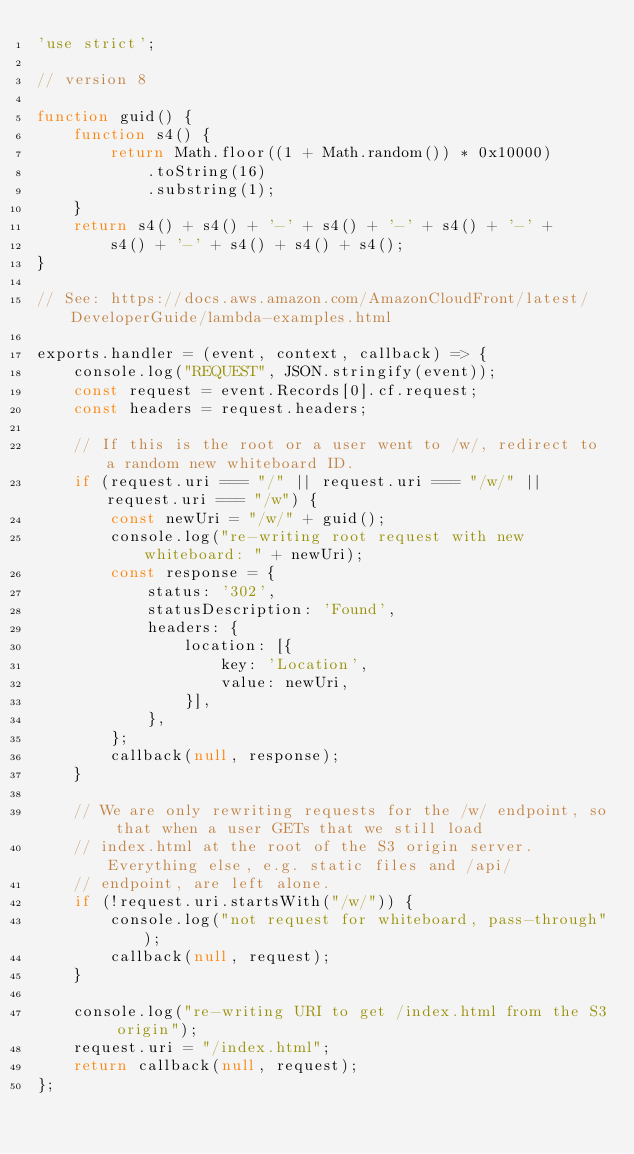Convert code to text. <code><loc_0><loc_0><loc_500><loc_500><_JavaScript_>'use strict';

// version 8

function guid() {
    function s4() {
        return Math.floor((1 + Math.random()) * 0x10000)
            .toString(16)
            .substring(1);
    }
    return s4() + s4() + '-' + s4() + '-' + s4() + '-' +
        s4() + '-' + s4() + s4() + s4();
}

// See: https://docs.aws.amazon.com/AmazonCloudFront/latest/DeveloperGuide/lambda-examples.html

exports.handler = (event, context, callback) => {
    console.log("REQUEST", JSON.stringify(event));
    const request = event.Records[0].cf.request;
    const headers = request.headers;

    // If this is the root or a user went to /w/, redirect to a random new whiteboard ID.
    if (request.uri === "/" || request.uri === "/w/" || request.uri === "/w") {
        const newUri = "/w/" + guid();
        console.log("re-writing root request with new whiteboard: " + newUri);
        const response = {
            status: '302',
            statusDescription: 'Found',
            headers: {
                location: [{
                    key: 'Location',
                    value: newUri,
                }],
            },
        };
        callback(null, response);
    }

    // We are only rewriting requests for the /w/ endpoint, so that when a user GETs that we still load
    // index.html at the root of the S3 origin server. Everything else, e.g. static files and /api/
    // endpoint, are left alone.
    if (!request.uri.startsWith("/w/")) {
        console.log("not request for whiteboard, pass-through");
        callback(null, request);
    }

    console.log("re-writing URI to get /index.html from the S3 origin");
    request.uri = "/index.html";
    return callback(null, request);
};
</code> 